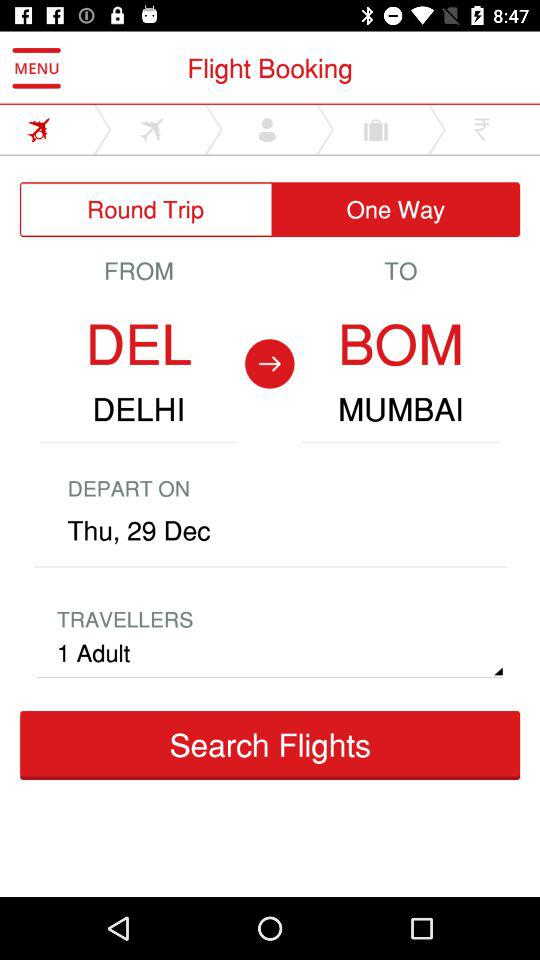What day is it on the given date? The day is Thursday. 